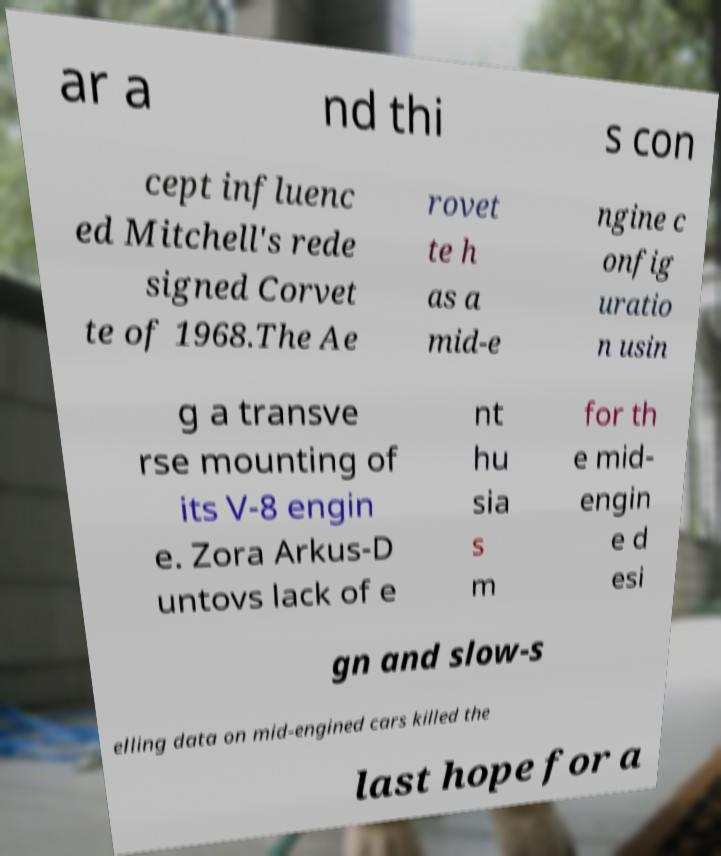For documentation purposes, I need the text within this image transcribed. Could you provide that? ar a nd thi s con cept influenc ed Mitchell's rede signed Corvet te of 1968.The Ae rovet te h as a mid-e ngine c onfig uratio n usin g a transve rse mounting of its V-8 engin e. Zora Arkus-D untovs lack of e nt hu sia s m for th e mid- engin e d esi gn and slow-s elling data on mid-engined cars killed the last hope for a 